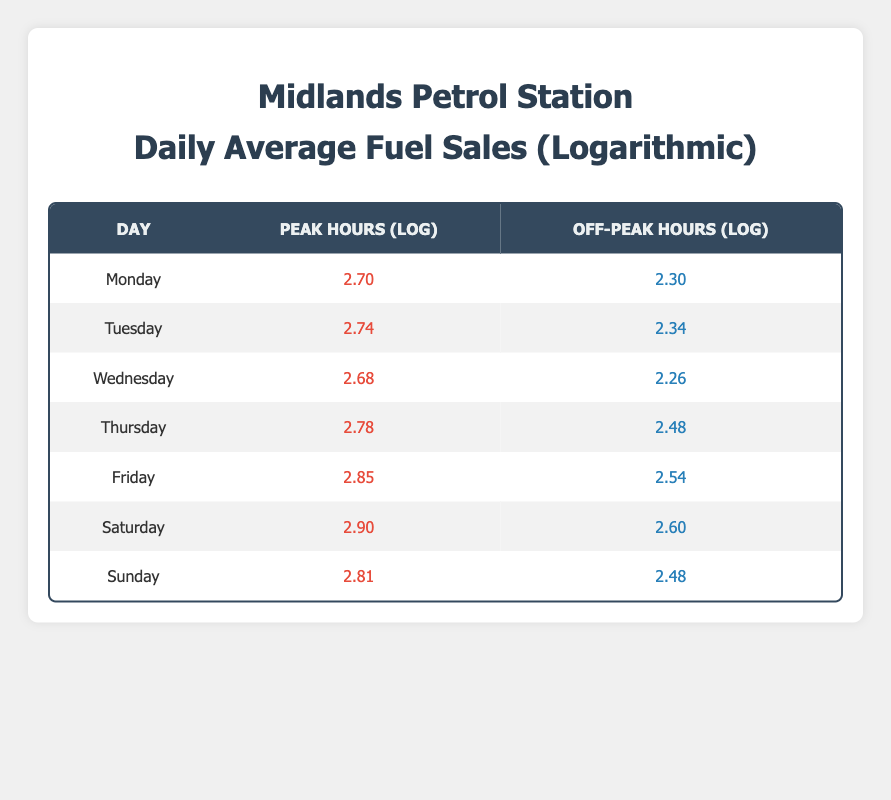What is the peak hour fuel sales on Friday? The table shows the peak hours for each day of the week. On Friday, the peak hour fuel sales are 700.
Answer: 700 What is the off-peak hour fuel sales for Saturday? The table indicates that the off-peak hour fuel sales for Saturday are 400.
Answer: 400 Which day has the highest off-peak hour fuel sales? By comparing the off-peak sales for each day in the table, Saturday has the highest off-peak hour sales at 400.
Answer: Saturday What is the difference in peak hour sales between Wednesday and Thursday? The peak hour sales for Wednesday is 480 and for Thursday is 600. The difference is calculated as 600 - 480 = 120.
Answer: 120 Is the off-peak hour fuel sales for Monday greater than that of Wednesday? From the table, the off-peak hour sales for Monday is 200 and for Wednesday is 180. Since 200 is greater than 180, the statement is true.
Answer: Yes Which day had the lowest peak hour fuel sales? Comparing peak hour sales from the table, Wednesday has the lowest at 480.
Answer: Wednesday What is the total peak hour fuel sales from Tuesday to Friday? The peak sales for these days are Tuesday (550), Wednesday (480), Thursday (600), and Friday (700). Summing them gives 550 + 480 + 600 + 700 = 2330.
Answer: 2330 What is the average peak hour fuel sales for the entire week? To find the average, we first sum up the peak sales (500 + 550 + 480 + 600 + 700 + 800 + 650 = 3790) and then divide by the number of days (7), which gives 3790 / 7 = 541.43.
Answer: 541.43 During which hour category is the fuel sales generally higher? By examining peak and off-peak hours for each day in the table, it's clear that peak hour sales are higher than off-peak sales as the maximum (800) exceeds the maximum in off-peak (400).
Answer: Peak hours 